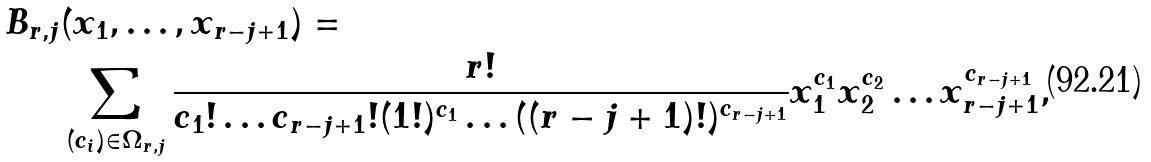<formula> <loc_0><loc_0><loc_500><loc_500>B _ { r , j } & ( x _ { 1 } , \dots , x _ { r - j + 1 } ) = \\ & \sum _ { ( c _ { i } ) \in \Omega _ { r , j } } \frac { r ! } { c _ { 1 } ! \dots c _ { r - j + 1 } ! ( 1 ! ) ^ { c _ { 1 } } \dots ( ( r - j + 1 ) ! ) ^ { c _ { r - j + 1 } } } x _ { 1 } ^ { c _ { 1 } } x _ { 2 } ^ { c _ { 2 } } \dots x _ { r - j + 1 } ^ { c _ { r - j + 1 } } ,</formula> 